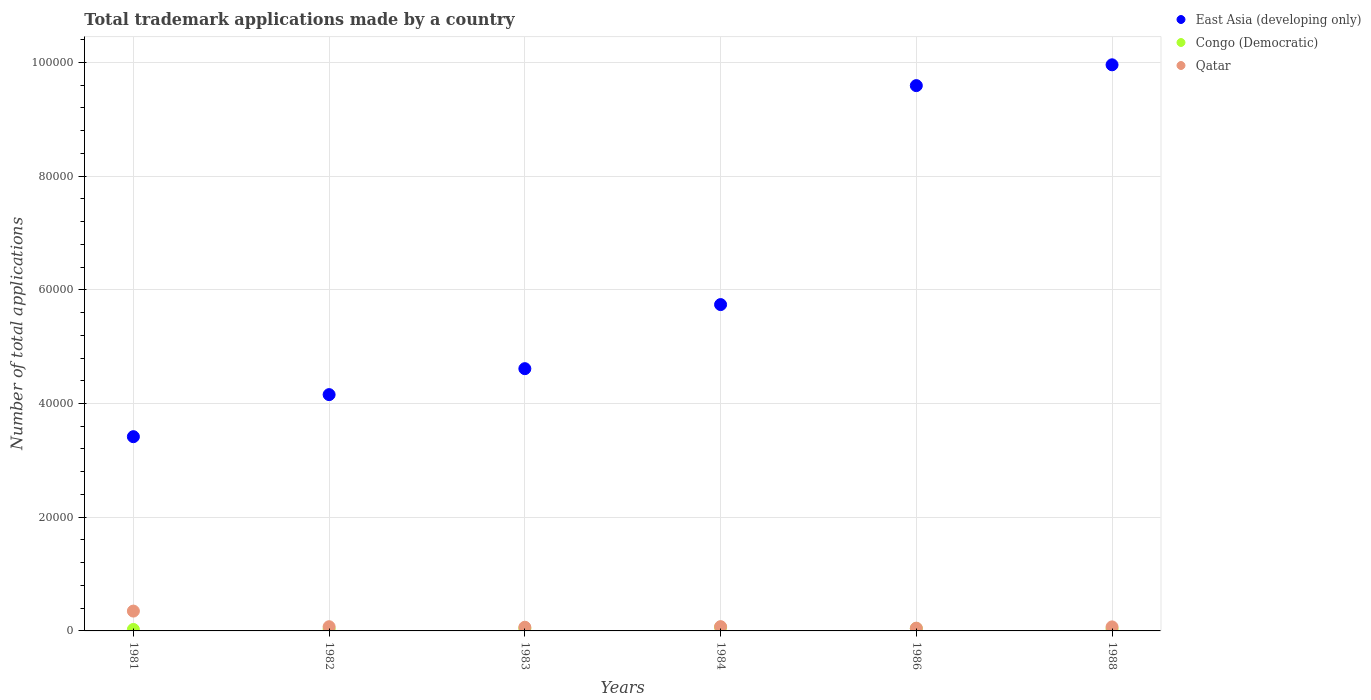How many different coloured dotlines are there?
Provide a succinct answer. 3. Is the number of dotlines equal to the number of legend labels?
Your answer should be very brief. Yes. What is the number of applications made by in Qatar in 1986?
Provide a succinct answer. 484. Across all years, what is the maximum number of applications made by in Congo (Democratic)?
Provide a short and direct response. 631. Across all years, what is the minimum number of applications made by in Congo (Democratic)?
Your answer should be very brief. 258. In which year was the number of applications made by in Qatar maximum?
Offer a terse response. 1981. In which year was the number of applications made by in Congo (Democratic) minimum?
Your answer should be very brief. 1981. What is the total number of applications made by in Qatar in the graph?
Give a very brief answer. 6817. What is the difference between the number of applications made by in Congo (Democratic) in 1981 and that in 1984?
Keep it short and to the point. -373. What is the difference between the number of applications made by in Qatar in 1988 and the number of applications made by in Congo (Democratic) in 1983?
Give a very brief answer. 283. What is the average number of applications made by in Qatar per year?
Provide a succinct answer. 1136.17. In the year 1986, what is the difference between the number of applications made by in East Asia (developing only) and number of applications made by in Qatar?
Make the answer very short. 9.54e+04. In how many years, is the number of applications made by in Congo (Democratic) greater than 32000?
Your response must be concise. 0. What is the ratio of the number of applications made by in East Asia (developing only) in 1981 to that in 1988?
Offer a terse response. 0.34. What is the difference between the highest and the second highest number of applications made by in Qatar?
Provide a succinct answer. 2737. What is the difference between the highest and the lowest number of applications made by in Congo (Democratic)?
Ensure brevity in your answer.  373. In how many years, is the number of applications made by in East Asia (developing only) greater than the average number of applications made by in East Asia (developing only) taken over all years?
Give a very brief answer. 2. Is the sum of the number of applications made by in East Asia (developing only) in 1981 and 1982 greater than the maximum number of applications made by in Congo (Democratic) across all years?
Provide a short and direct response. Yes. Is it the case that in every year, the sum of the number of applications made by in East Asia (developing only) and number of applications made by in Qatar  is greater than the number of applications made by in Congo (Democratic)?
Give a very brief answer. Yes. Is the number of applications made by in Qatar strictly greater than the number of applications made by in Congo (Democratic) over the years?
Give a very brief answer. Yes. Is the number of applications made by in Congo (Democratic) strictly less than the number of applications made by in Qatar over the years?
Give a very brief answer. Yes. Are the values on the major ticks of Y-axis written in scientific E-notation?
Your response must be concise. No. Does the graph contain grids?
Provide a succinct answer. Yes. How are the legend labels stacked?
Your answer should be very brief. Vertical. What is the title of the graph?
Provide a succinct answer. Total trademark applications made by a country. What is the label or title of the Y-axis?
Ensure brevity in your answer.  Number of total applications. What is the Number of total applications of East Asia (developing only) in 1981?
Your answer should be compact. 3.42e+04. What is the Number of total applications in Congo (Democratic) in 1981?
Offer a terse response. 258. What is the Number of total applications in Qatar in 1981?
Give a very brief answer. 3489. What is the Number of total applications in East Asia (developing only) in 1982?
Give a very brief answer. 4.16e+04. What is the Number of total applications of Congo (Democratic) in 1982?
Provide a short and direct response. 350. What is the Number of total applications in Qatar in 1982?
Your answer should be compact. 739. What is the Number of total applications in East Asia (developing only) in 1983?
Offer a terse response. 4.61e+04. What is the Number of total applications in Congo (Democratic) in 1983?
Offer a very short reply. 424. What is the Number of total applications in Qatar in 1983?
Your answer should be compact. 646. What is the Number of total applications of East Asia (developing only) in 1984?
Give a very brief answer. 5.74e+04. What is the Number of total applications of Congo (Democratic) in 1984?
Give a very brief answer. 631. What is the Number of total applications of Qatar in 1984?
Your answer should be very brief. 752. What is the Number of total applications of East Asia (developing only) in 1986?
Your response must be concise. 9.59e+04. What is the Number of total applications of Congo (Democratic) in 1986?
Provide a succinct answer. 424. What is the Number of total applications of Qatar in 1986?
Offer a very short reply. 484. What is the Number of total applications in East Asia (developing only) in 1988?
Offer a very short reply. 9.96e+04. What is the Number of total applications in Congo (Democratic) in 1988?
Your response must be concise. 340. What is the Number of total applications in Qatar in 1988?
Give a very brief answer. 707. Across all years, what is the maximum Number of total applications in East Asia (developing only)?
Give a very brief answer. 9.96e+04. Across all years, what is the maximum Number of total applications of Congo (Democratic)?
Keep it short and to the point. 631. Across all years, what is the maximum Number of total applications of Qatar?
Provide a succinct answer. 3489. Across all years, what is the minimum Number of total applications in East Asia (developing only)?
Offer a very short reply. 3.42e+04. Across all years, what is the minimum Number of total applications in Congo (Democratic)?
Offer a very short reply. 258. Across all years, what is the minimum Number of total applications of Qatar?
Ensure brevity in your answer.  484. What is the total Number of total applications of East Asia (developing only) in the graph?
Give a very brief answer. 3.75e+05. What is the total Number of total applications in Congo (Democratic) in the graph?
Give a very brief answer. 2427. What is the total Number of total applications of Qatar in the graph?
Make the answer very short. 6817. What is the difference between the Number of total applications of East Asia (developing only) in 1981 and that in 1982?
Offer a terse response. -7397. What is the difference between the Number of total applications of Congo (Democratic) in 1981 and that in 1982?
Offer a very short reply. -92. What is the difference between the Number of total applications in Qatar in 1981 and that in 1982?
Give a very brief answer. 2750. What is the difference between the Number of total applications in East Asia (developing only) in 1981 and that in 1983?
Provide a short and direct response. -1.20e+04. What is the difference between the Number of total applications in Congo (Democratic) in 1981 and that in 1983?
Give a very brief answer. -166. What is the difference between the Number of total applications of Qatar in 1981 and that in 1983?
Ensure brevity in your answer.  2843. What is the difference between the Number of total applications in East Asia (developing only) in 1981 and that in 1984?
Your answer should be very brief. -2.32e+04. What is the difference between the Number of total applications in Congo (Democratic) in 1981 and that in 1984?
Provide a succinct answer. -373. What is the difference between the Number of total applications in Qatar in 1981 and that in 1984?
Ensure brevity in your answer.  2737. What is the difference between the Number of total applications in East Asia (developing only) in 1981 and that in 1986?
Offer a very short reply. -6.17e+04. What is the difference between the Number of total applications of Congo (Democratic) in 1981 and that in 1986?
Make the answer very short. -166. What is the difference between the Number of total applications in Qatar in 1981 and that in 1986?
Make the answer very short. 3005. What is the difference between the Number of total applications in East Asia (developing only) in 1981 and that in 1988?
Give a very brief answer. -6.54e+04. What is the difference between the Number of total applications in Congo (Democratic) in 1981 and that in 1988?
Offer a terse response. -82. What is the difference between the Number of total applications of Qatar in 1981 and that in 1988?
Ensure brevity in your answer.  2782. What is the difference between the Number of total applications of East Asia (developing only) in 1982 and that in 1983?
Keep it short and to the point. -4564. What is the difference between the Number of total applications of Congo (Democratic) in 1982 and that in 1983?
Offer a terse response. -74. What is the difference between the Number of total applications of Qatar in 1982 and that in 1983?
Your answer should be very brief. 93. What is the difference between the Number of total applications in East Asia (developing only) in 1982 and that in 1984?
Offer a terse response. -1.58e+04. What is the difference between the Number of total applications of Congo (Democratic) in 1982 and that in 1984?
Keep it short and to the point. -281. What is the difference between the Number of total applications in East Asia (developing only) in 1982 and that in 1986?
Make the answer very short. -5.43e+04. What is the difference between the Number of total applications of Congo (Democratic) in 1982 and that in 1986?
Provide a short and direct response. -74. What is the difference between the Number of total applications of Qatar in 1982 and that in 1986?
Provide a short and direct response. 255. What is the difference between the Number of total applications of East Asia (developing only) in 1982 and that in 1988?
Provide a short and direct response. -5.80e+04. What is the difference between the Number of total applications of Congo (Democratic) in 1982 and that in 1988?
Keep it short and to the point. 10. What is the difference between the Number of total applications of East Asia (developing only) in 1983 and that in 1984?
Provide a short and direct response. -1.13e+04. What is the difference between the Number of total applications of Congo (Democratic) in 1983 and that in 1984?
Make the answer very short. -207. What is the difference between the Number of total applications in Qatar in 1983 and that in 1984?
Your answer should be compact. -106. What is the difference between the Number of total applications of East Asia (developing only) in 1983 and that in 1986?
Your answer should be very brief. -4.98e+04. What is the difference between the Number of total applications of Congo (Democratic) in 1983 and that in 1986?
Provide a short and direct response. 0. What is the difference between the Number of total applications of Qatar in 1983 and that in 1986?
Provide a short and direct response. 162. What is the difference between the Number of total applications in East Asia (developing only) in 1983 and that in 1988?
Offer a terse response. -5.34e+04. What is the difference between the Number of total applications in Qatar in 1983 and that in 1988?
Offer a terse response. -61. What is the difference between the Number of total applications in East Asia (developing only) in 1984 and that in 1986?
Provide a succinct answer. -3.85e+04. What is the difference between the Number of total applications in Congo (Democratic) in 1984 and that in 1986?
Offer a terse response. 207. What is the difference between the Number of total applications of Qatar in 1984 and that in 1986?
Give a very brief answer. 268. What is the difference between the Number of total applications in East Asia (developing only) in 1984 and that in 1988?
Ensure brevity in your answer.  -4.22e+04. What is the difference between the Number of total applications of Congo (Democratic) in 1984 and that in 1988?
Your answer should be very brief. 291. What is the difference between the Number of total applications of Qatar in 1984 and that in 1988?
Ensure brevity in your answer.  45. What is the difference between the Number of total applications of East Asia (developing only) in 1986 and that in 1988?
Provide a short and direct response. -3661. What is the difference between the Number of total applications of Qatar in 1986 and that in 1988?
Make the answer very short. -223. What is the difference between the Number of total applications in East Asia (developing only) in 1981 and the Number of total applications in Congo (Democratic) in 1982?
Keep it short and to the point. 3.38e+04. What is the difference between the Number of total applications in East Asia (developing only) in 1981 and the Number of total applications in Qatar in 1982?
Provide a succinct answer. 3.34e+04. What is the difference between the Number of total applications of Congo (Democratic) in 1981 and the Number of total applications of Qatar in 1982?
Your answer should be compact. -481. What is the difference between the Number of total applications of East Asia (developing only) in 1981 and the Number of total applications of Congo (Democratic) in 1983?
Your response must be concise. 3.37e+04. What is the difference between the Number of total applications of East Asia (developing only) in 1981 and the Number of total applications of Qatar in 1983?
Keep it short and to the point. 3.35e+04. What is the difference between the Number of total applications in Congo (Democratic) in 1981 and the Number of total applications in Qatar in 1983?
Provide a short and direct response. -388. What is the difference between the Number of total applications of East Asia (developing only) in 1981 and the Number of total applications of Congo (Democratic) in 1984?
Ensure brevity in your answer.  3.35e+04. What is the difference between the Number of total applications of East Asia (developing only) in 1981 and the Number of total applications of Qatar in 1984?
Ensure brevity in your answer.  3.34e+04. What is the difference between the Number of total applications in Congo (Democratic) in 1981 and the Number of total applications in Qatar in 1984?
Provide a short and direct response. -494. What is the difference between the Number of total applications of East Asia (developing only) in 1981 and the Number of total applications of Congo (Democratic) in 1986?
Offer a terse response. 3.37e+04. What is the difference between the Number of total applications of East Asia (developing only) in 1981 and the Number of total applications of Qatar in 1986?
Provide a succinct answer. 3.37e+04. What is the difference between the Number of total applications of Congo (Democratic) in 1981 and the Number of total applications of Qatar in 1986?
Make the answer very short. -226. What is the difference between the Number of total applications of East Asia (developing only) in 1981 and the Number of total applications of Congo (Democratic) in 1988?
Keep it short and to the point. 3.38e+04. What is the difference between the Number of total applications of East Asia (developing only) in 1981 and the Number of total applications of Qatar in 1988?
Offer a terse response. 3.35e+04. What is the difference between the Number of total applications of Congo (Democratic) in 1981 and the Number of total applications of Qatar in 1988?
Your response must be concise. -449. What is the difference between the Number of total applications in East Asia (developing only) in 1982 and the Number of total applications in Congo (Democratic) in 1983?
Give a very brief answer. 4.11e+04. What is the difference between the Number of total applications in East Asia (developing only) in 1982 and the Number of total applications in Qatar in 1983?
Make the answer very short. 4.09e+04. What is the difference between the Number of total applications in Congo (Democratic) in 1982 and the Number of total applications in Qatar in 1983?
Offer a terse response. -296. What is the difference between the Number of total applications of East Asia (developing only) in 1982 and the Number of total applications of Congo (Democratic) in 1984?
Make the answer very short. 4.09e+04. What is the difference between the Number of total applications in East Asia (developing only) in 1982 and the Number of total applications in Qatar in 1984?
Offer a very short reply. 4.08e+04. What is the difference between the Number of total applications of Congo (Democratic) in 1982 and the Number of total applications of Qatar in 1984?
Ensure brevity in your answer.  -402. What is the difference between the Number of total applications in East Asia (developing only) in 1982 and the Number of total applications in Congo (Democratic) in 1986?
Keep it short and to the point. 4.11e+04. What is the difference between the Number of total applications in East Asia (developing only) in 1982 and the Number of total applications in Qatar in 1986?
Give a very brief answer. 4.11e+04. What is the difference between the Number of total applications of Congo (Democratic) in 1982 and the Number of total applications of Qatar in 1986?
Provide a succinct answer. -134. What is the difference between the Number of total applications in East Asia (developing only) in 1982 and the Number of total applications in Congo (Democratic) in 1988?
Keep it short and to the point. 4.12e+04. What is the difference between the Number of total applications in East Asia (developing only) in 1982 and the Number of total applications in Qatar in 1988?
Make the answer very short. 4.09e+04. What is the difference between the Number of total applications of Congo (Democratic) in 1982 and the Number of total applications of Qatar in 1988?
Your answer should be very brief. -357. What is the difference between the Number of total applications of East Asia (developing only) in 1983 and the Number of total applications of Congo (Democratic) in 1984?
Provide a short and direct response. 4.55e+04. What is the difference between the Number of total applications of East Asia (developing only) in 1983 and the Number of total applications of Qatar in 1984?
Provide a succinct answer. 4.54e+04. What is the difference between the Number of total applications of Congo (Democratic) in 1983 and the Number of total applications of Qatar in 1984?
Give a very brief answer. -328. What is the difference between the Number of total applications of East Asia (developing only) in 1983 and the Number of total applications of Congo (Democratic) in 1986?
Provide a short and direct response. 4.57e+04. What is the difference between the Number of total applications of East Asia (developing only) in 1983 and the Number of total applications of Qatar in 1986?
Make the answer very short. 4.56e+04. What is the difference between the Number of total applications of Congo (Democratic) in 1983 and the Number of total applications of Qatar in 1986?
Your answer should be compact. -60. What is the difference between the Number of total applications in East Asia (developing only) in 1983 and the Number of total applications in Congo (Democratic) in 1988?
Give a very brief answer. 4.58e+04. What is the difference between the Number of total applications of East Asia (developing only) in 1983 and the Number of total applications of Qatar in 1988?
Make the answer very short. 4.54e+04. What is the difference between the Number of total applications in Congo (Democratic) in 1983 and the Number of total applications in Qatar in 1988?
Give a very brief answer. -283. What is the difference between the Number of total applications in East Asia (developing only) in 1984 and the Number of total applications in Congo (Democratic) in 1986?
Provide a succinct answer. 5.70e+04. What is the difference between the Number of total applications in East Asia (developing only) in 1984 and the Number of total applications in Qatar in 1986?
Your answer should be very brief. 5.69e+04. What is the difference between the Number of total applications in Congo (Democratic) in 1984 and the Number of total applications in Qatar in 1986?
Give a very brief answer. 147. What is the difference between the Number of total applications in East Asia (developing only) in 1984 and the Number of total applications in Congo (Democratic) in 1988?
Offer a very short reply. 5.71e+04. What is the difference between the Number of total applications of East Asia (developing only) in 1984 and the Number of total applications of Qatar in 1988?
Give a very brief answer. 5.67e+04. What is the difference between the Number of total applications in Congo (Democratic) in 1984 and the Number of total applications in Qatar in 1988?
Offer a very short reply. -76. What is the difference between the Number of total applications in East Asia (developing only) in 1986 and the Number of total applications in Congo (Democratic) in 1988?
Offer a terse response. 9.56e+04. What is the difference between the Number of total applications in East Asia (developing only) in 1986 and the Number of total applications in Qatar in 1988?
Keep it short and to the point. 9.52e+04. What is the difference between the Number of total applications of Congo (Democratic) in 1986 and the Number of total applications of Qatar in 1988?
Offer a terse response. -283. What is the average Number of total applications of East Asia (developing only) per year?
Your answer should be very brief. 6.25e+04. What is the average Number of total applications in Congo (Democratic) per year?
Your response must be concise. 404.5. What is the average Number of total applications of Qatar per year?
Your answer should be very brief. 1136.17. In the year 1981, what is the difference between the Number of total applications in East Asia (developing only) and Number of total applications in Congo (Democratic)?
Provide a succinct answer. 3.39e+04. In the year 1981, what is the difference between the Number of total applications of East Asia (developing only) and Number of total applications of Qatar?
Give a very brief answer. 3.07e+04. In the year 1981, what is the difference between the Number of total applications of Congo (Democratic) and Number of total applications of Qatar?
Offer a terse response. -3231. In the year 1982, what is the difference between the Number of total applications of East Asia (developing only) and Number of total applications of Congo (Democratic)?
Your answer should be compact. 4.12e+04. In the year 1982, what is the difference between the Number of total applications of East Asia (developing only) and Number of total applications of Qatar?
Ensure brevity in your answer.  4.08e+04. In the year 1982, what is the difference between the Number of total applications in Congo (Democratic) and Number of total applications in Qatar?
Your response must be concise. -389. In the year 1983, what is the difference between the Number of total applications of East Asia (developing only) and Number of total applications of Congo (Democratic)?
Make the answer very short. 4.57e+04. In the year 1983, what is the difference between the Number of total applications in East Asia (developing only) and Number of total applications in Qatar?
Provide a short and direct response. 4.55e+04. In the year 1983, what is the difference between the Number of total applications in Congo (Democratic) and Number of total applications in Qatar?
Give a very brief answer. -222. In the year 1984, what is the difference between the Number of total applications of East Asia (developing only) and Number of total applications of Congo (Democratic)?
Ensure brevity in your answer.  5.68e+04. In the year 1984, what is the difference between the Number of total applications in East Asia (developing only) and Number of total applications in Qatar?
Keep it short and to the point. 5.66e+04. In the year 1984, what is the difference between the Number of total applications of Congo (Democratic) and Number of total applications of Qatar?
Keep it short and to the point. -121. In the year 1986, what is the difference between the Number of total applications of East Asia (developing only) and Number of total applications of Congo (Democratic)?
Offer a very short reply. 9.55e+04. In the year 1986, what is the difference between the Number of total applications of East Asia (developing only) and Number of total applications of Qatar?
Offer a terse response. 9.54e+04. In the year 1986, what is the difference between the Number of total applications of Congo (Democratic) and Number of total applications of Qatar?
Offer a very short reply. -60. In the year 1988, what is the difference between the Number of total applications of East Asia (developing only) and Number of total applications of Congo (Democratic)?
Offer a terse response. 9.92e+04. In the year 1988, what is the difference between the Number of total applications of East Asia (developing only) and Number of total applications of Qatar?
Make the answer very short. 9.89e+04. In the year 1988, what is the difference between the Number of total applications in Congo (Democratic) and Number of total applications in Qatar?
Offer a very short reply. -367. What is the ratio of the Number of total applications of East Asia (developing only) in 1981 to that in 1982?
Your answer should be very brief. 0.82. What is the ratio of the Number of total applications in Congo (Democratic) in 1981 to that in 1982?
Your response must be concise. 0.74. What is the ratio of the Number of total applications in Qatar in 1981 to that in 1982?
Your answer should be very brief. 4.72. What is the ratio of the Number of total applications in East Asia (developing only) in 1981 to that in 1983?
Provide a short and direct response. 0.74. What is the ratio of the Number of total applications in Congo (Democratic) in 1981 to that in 1983?
Make the answer very short. 0.61. What is the ratio of the Number of total applications in Qatar in 1981 to that in 1983?
Provide a succinct answer. 5.4. What is the ratio of the Number of total applications in East Asia (developing only) in 1981 to that in 1984?
Offer a very short reply. 0.6. What is the ratio of the Number of total applications in Congo (Democratic) in 1981 to that in 1984?
Your response must be concise. 0.41. What is the ratio of the Number of total applications of Qatar in 1981 to that in 1984?
Ensure brevity in your answer.  4.64. What is the ratio of the Number of total applications of East Asia (developing only) in 1981 to that in 1986?
Ensure brevity in your answer.  0.36. What is the ratio of the Number of total applications of Congo (Democratic) in 1981 to that in 1986?
Keep it short and to the point. 0.61. What is the ratio of the Number of total applications of Qatar in 1981 to that in 1986?
Your response must be concise. 7.21. What is the ratio of the Number of total applications in East Asia (developing only) in 1981 to that in 1988?
Ensure brevity in your answer.  0.34. What is the ratio of the Number of total applications of Congo (Democratic) in 1981 to that in 1988?
Offer a very short reply. 0.76. What is the ratio of the Number of total applications in Qatar in 1981 to that in 1988?
Offer a very short reply. 4.93. What is the ratio of the Number of total applications of East Asia (developing only) in 1982 to that in 1983?
Offer a very short reply. 0.9. What is the ratio of the Number of total applications in Congo (Democratic) in 1982 to that in 1983?
Your response must be concise. 0.83. What is the ratio of the Number of total applications of Qatar in 1982 to that in 1983?
Provide a succinct answer. 1.14. What is the ratio of the Number of total applications in East Asia (developing only) in 1982 to that in 1984?
Make the answer very short. 0.72. What is the ratio of the Number of total applications in Congo (Democratic) in 1982 to that in 1984?
Provide a short and direct response. 0.55. What is the ratio of the Number of total applications of Qatar in 1982 to that in 1984?
Offer a very short reply. 0.98. What is the ratio of the Number of total applications of East Asia (developing only) in 1982 to that in 1986?
Your response must be concise. 0.43. What is the ratio of the Number of total applications in Congo (Democratic) in 1982 to that in 1986?
Keep it short and to the point. 0.83. What is the ratio of the Number of total applications of Qatar in 1982 to that in 1986?
Keep it short and to the point. 1.53. What is the ratio of the Number of total applications of East Asia (developing only) in 1982 to that in 1988?
Provide a succinct answer. 0.42. What is the ratio of the Number of total applications of Congo (Democratic) in 1982 to that in 1988?
Offer a terse response. 1.03. What is the ratio of the Number of total applications in Qatar in 1982 to that in 1988?
Your response must be concise. 1.05. What is the ratio of the Number of total applications of East Asia (developing only) in 1983 to that in 1984?
Offer a terse response. 0.8. What is the ratio of the Number of total applications in Congo (Democratic) in 1983 to that in 1984?
Keep it short and to the point. 0.67. What is the ratio of the Number of total applications in Qatar in 1983 to that in 1984?
Your answer should be compact. 0.86. What is the ratio of the Number of total applications of East Asia (developing only) in 1983 to that in 1986?
Offer a terse response. 0.48. What is the ratio of the Number of total applications of Congo (Democratic) in 1983 to that in 1986?
Offer a terse response. 1. What is the ratio of the Number of total applications of Qatar in 1983 to that in 1986?
Your response must be concise. 1.33. What is the ratio of the Number of total applications in East Asia (developing only) in 1983 to that in 1988?
Give a very brief answer. 0.46. What is the ratio of the Number of total applications of Congo (Democratic) in 1983 to that in 1988?
Your answer should be very brief. 1.25. What is the ratio of the Number of total applications of Qatar in 1983 to that in 1988?
Provide a succinct answer. 0.91. What is the ratio of the Number of total applications of East Asia (developing only) in 1984 to that in 1986?
Ensure brevity in your answer.  0.6. What is the ratio of the Number of total applications in Congo (Democratic) in 1984 to that in 1986?
Ensure brevity in your answer.  1.49. What is the ratio of the Number of total applications in Qatar in 1984 to that in 1986?
Your response must be concise. 1.55. What is the ratio of the Number of total applications of East Asia (developing only) in 1984 to that in 1988?
Your answer should be very brief. 0.58. What is the ratio of the Number of total applications in Congo (Democratic) in 1984 to that in 1988?
Offer a terse response. 1.86. What is the ratio of the Number of total applications in Qatar in 1984 to that in 1988?
Your answer should be very brief. 1.06. What is the ratio of the Number of total applications of East Asia (developing only) in 1986 to that in 1988?
Give a very brief answer. 0.96. What is the ratio of the Number of total applications of Congo (Democratic) in 1986 to that in 1988?
Make the answer very short. 1.25. What is the ratio of the Number of total applications in Qatar in 1986 to that in 1988?
Keep it short and to the point. 0.68. What is the difference between the highest and the second highest Number of total applications in East Asia (developing only)?
Make the answer very short. 3661. What is the difference between the highest and the second highest Number of total applications in Congo (Democratic)?
Offer a very short reply. 207. What is the difference between the highest and the second highest Number of total applications in Qatar?
Provide a short and direct response. 2737. What is the difference between the highest and the lowest Number of total applications in East Asia (developing only)?
Ensure brevity in your answer.  6.54e+04. What is the difference between the highest and the lowest Number of total applications of Congo (Democratic)?
Give a very brief answer. 373. What is the difference between the highest and the lowest Number of total applications of Qatar?
Your response must be concise. 3005. 